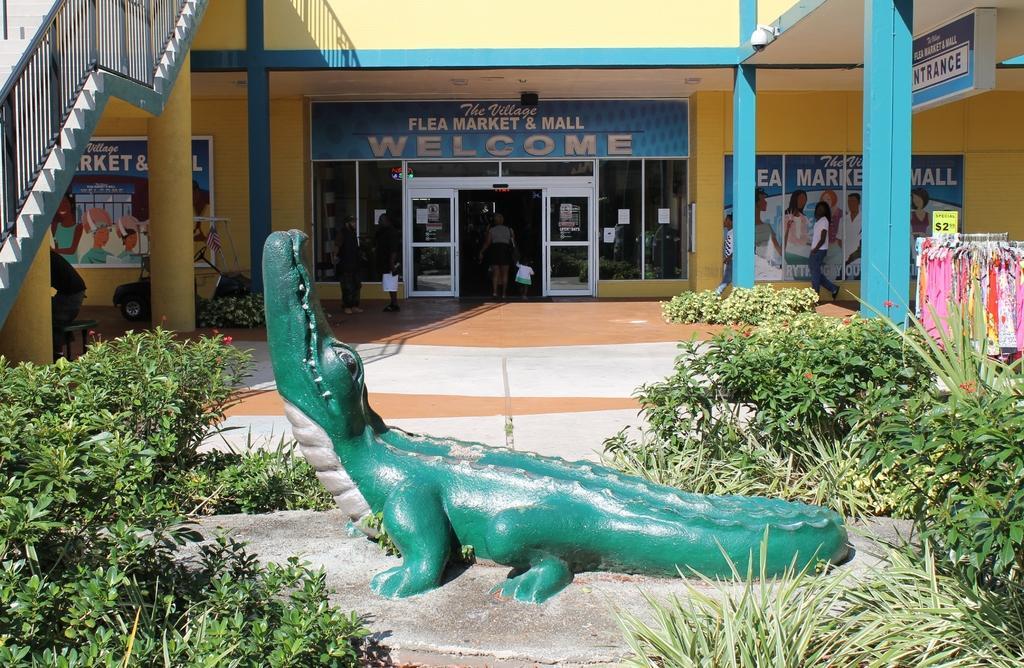Can you describe this image briefly? In the foreground of the picture there are plants and a sculpture of crocodile. On the left there are poster, staircase, pillars, person and other objects. In the center of the picture we can see windows, door, people, banner and wall. On the right there are plants, dresses, banner, person, pillars, wall, board and other objects. 